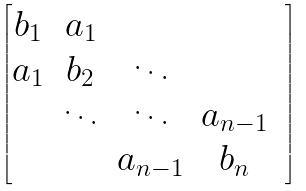<formula> <loc_0><loc_0><loc_500><loc_500>\begin{bmatrix} b _ { 1 } & a _ { 1 } & & \\ a _ { 1 } & b _ { 2 } & \ddots & & \\ & \ddots & \ddots & a _ { n - 1 } \\ & & a _ { n - 1 } & b _ { n } \end{bmatrix}</formula> 